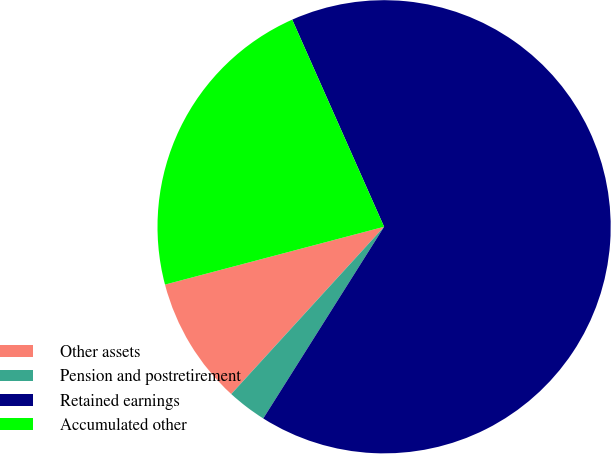Convert chart to OTSL. <chart><loc_0><loc_0><loc_500><loc_500><pie_chart><fcel>Other assets<fcel>Pension and postretirement<fcel>Retained earnings<fcel>Accumulated other<nl><fcel>9.11%<fcel>2.83%<fcel>65.59%<fcel>22.46%<nl></chart> 